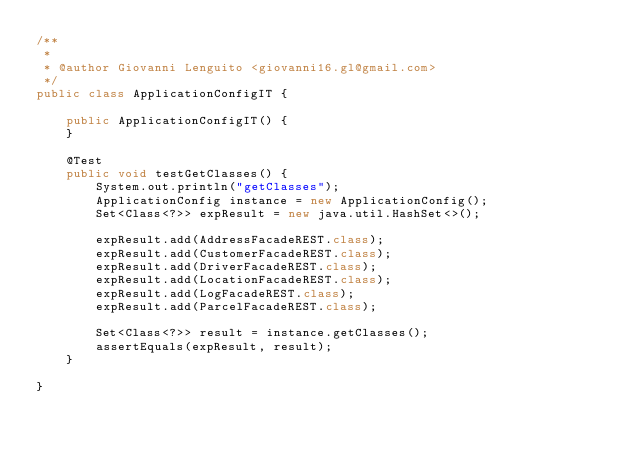Convert code to text. <code><loc_0><loc_0><loc_500><loc_500><_Java_>/**
 *
 * @author Giovanni Lenguito <giovanni16.gl@gmail.com>
 */
public class ApplicationConfigIT {
    
    public ApplicationConfigIT() {
    }

    @Test
    public void testGetClasses() {
        System.out.println("getClasses");
        ApplicationConfig instance = new ApplicationConfig();
        Set<Class<?>> expResult = new java.util.HashSet<>();
        
        expResult.add(AddressFacadeREST.class);
        expResult.add(CustomerFacadeREST.class);
        expResult.add(DriverFacadeREST.class);
        expResult.add(LocationFacadeREST.class);
        expResult.add(LogFacadeREST.class);
        expResult.add(ParcelFacadeREST.class);
        
        Set<Class<?>> result = instance.getClasses();
        assertEquals(expResult, result);
    }
    
}</code> 